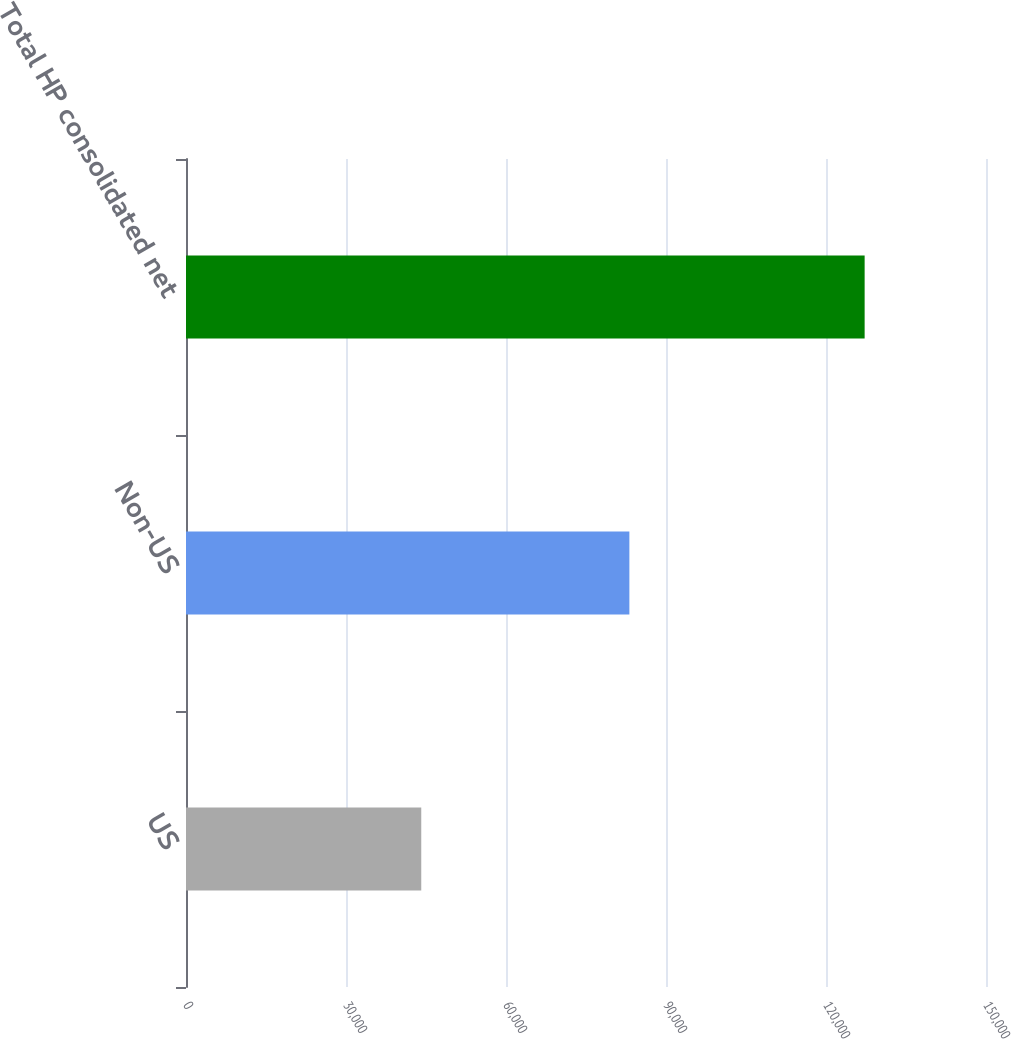Convert chart. <chart><loc_0><loc_0><loc_500><loc_500><bar_chart><fcel>US<fcel>Non-US<fcel>Total HP consolidated net<nl><fcel>44111<fcel>83134<fcel>127245<nl></chart> 